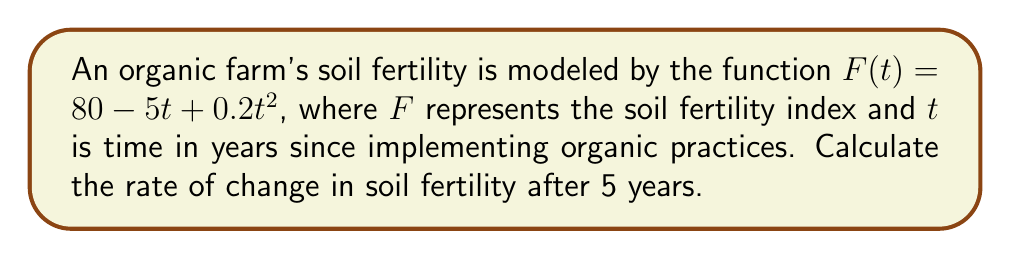Show me your answer to this math problem. To find the rate of change in soil fertility after 5 years, we need to calculate the derivative of $F(t)$ and evaluate it at $t=5$.

Step 1: Find the derivative of $F(t)$.
$$\frac{d}{dt}F(t) = \frac{d}{dt}(80 - 5t + 0.2t^2)$$
$$F'(t) = -5 + 0.4t$$

Step 2: Evaluate $F'(t)$ at $t=5$.
$$F'(5) = -5 + 0.4(5)$$
$$F'(5) = -5 + 2$$
$$F'(5) = -3$$

The negative value indicates that the soil fertility is decreasing at this point in time.
Answer: $-3$ units per year 